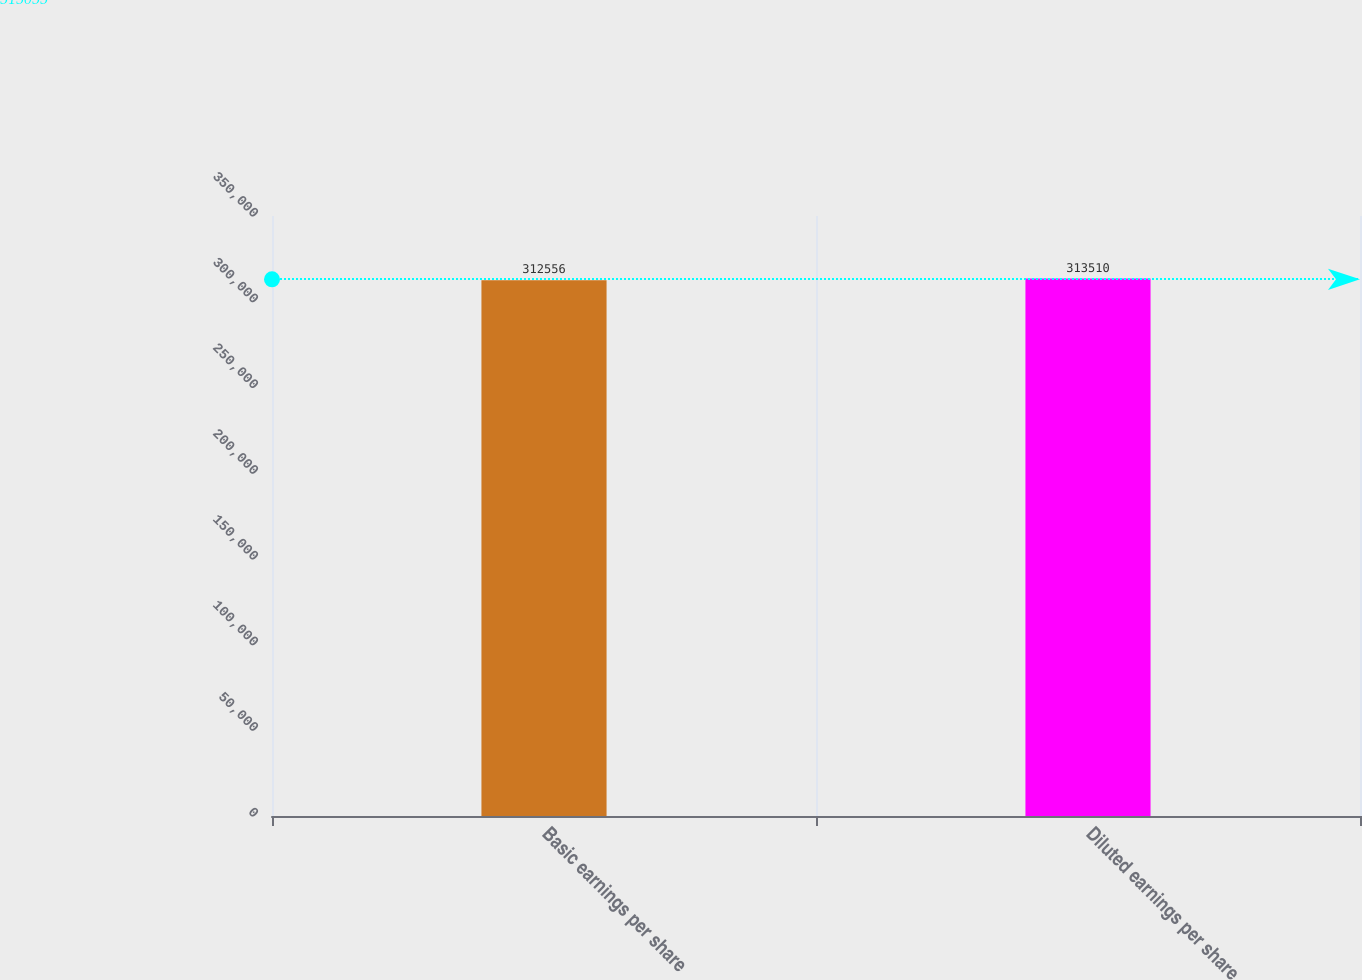<chart> <loc_0><loc_0><loc_500><loc_500><bar_chart><fcel>Basic earnings per share<fcel>Diluted earnings per share<nl><fcel>312556<fcel>313510<nl></chart> 